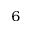Convert formula to latex. <formula><loc_0><loc_0><loc_500><loc_500>^ { 6 }</formula> 